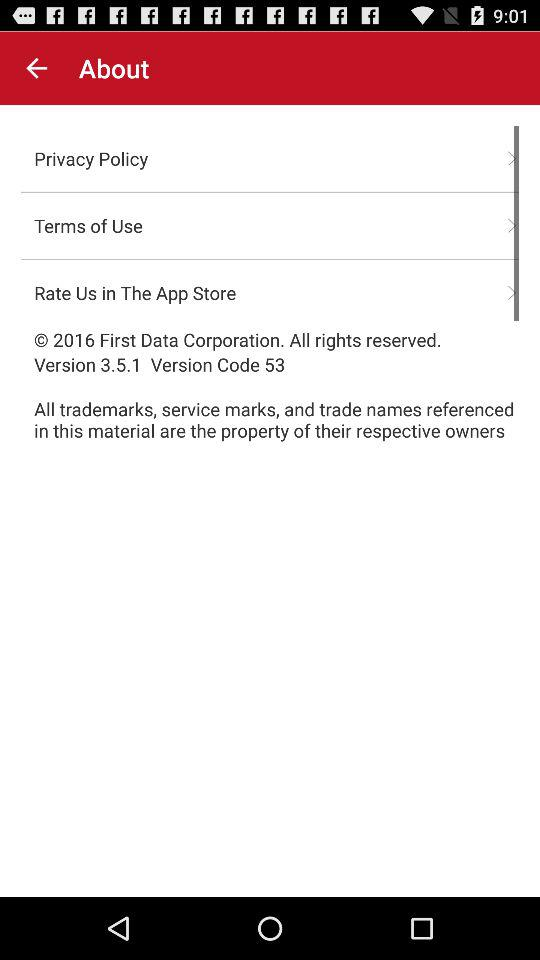What is the privacy policy?
When the provided information is insufficient, respond with <no answer>. <no answer> 